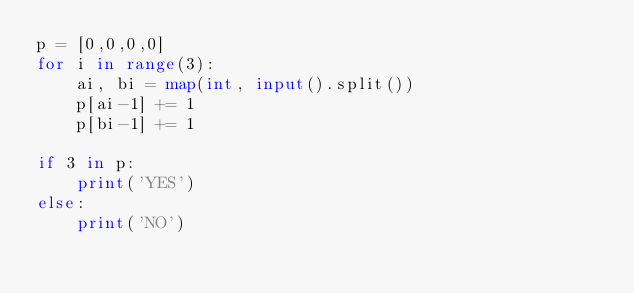<code> <loc_0><loc_0><loc_500><loc_500><_Python_>p = [0,0,0,0]
for i in range(3):
    ai, bi = map(int, input().split())
    p[ai-1] += 1
    p[bi-1] += 1

if 3 in p:
    print('YES')
else:
    print('NO')
</code> 